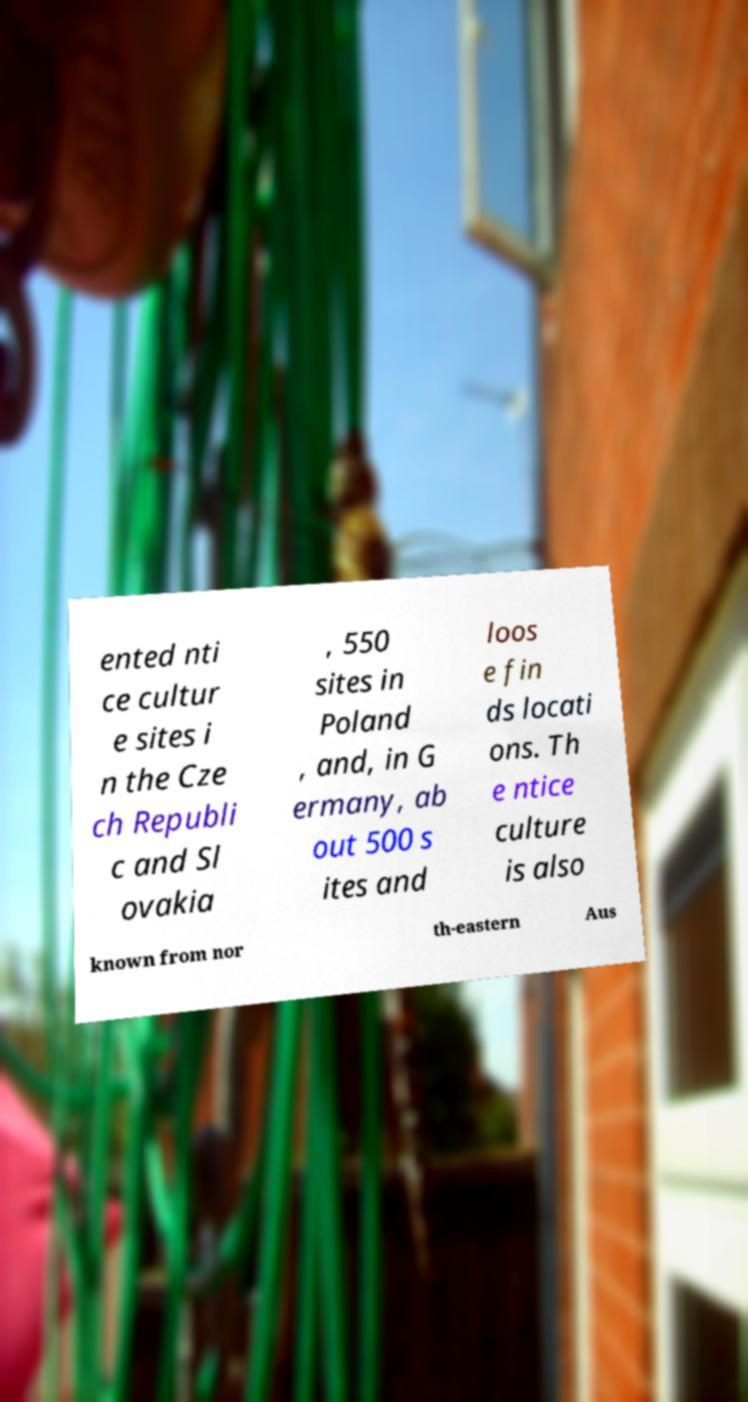For documentation purposes, I need the text within this image transcribed. Could you provide that? ented nti ce cultur e sites i n the Cze ch Republi c and Sl ovakia , 550 sites in Poland , and, in G ermany, ab out 500 s ites and loos e fin ds locati ons. Th e ntice culture is also known from nor th-eastern Aus 